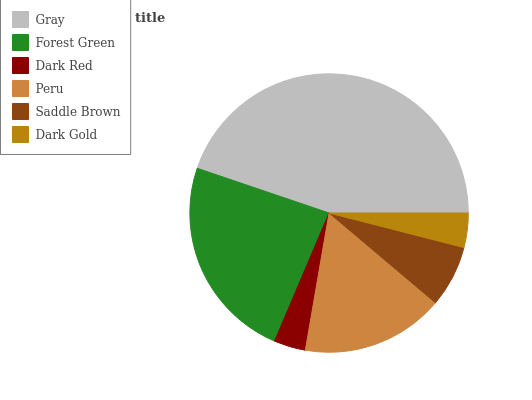Is Dark Red the minimum?
Answer yes or no. Yes. Is Gray the maximum?
Answer yes or no. Yes. Is Forest Green the minimum?
Answer yes or no. No. Is Forest Green the maximum?
Answer yes or no. No. Is Gray greater than Forest Green?
Answer yes or no. Yes. Is Forest Green less than Gray?
Answer yes or no. Yes. Is Forest Green greater than Gray?
Answer yes or no. No. Is Gray less than Forest Green?
Answer yes or no. No. Is Peru the high median?
Answer yes or no. Yes. Is Saddle Brown the low median?
Answer yes or no. Yes. Is Gray the high median?
Answer yes or no. No. Is Gray the low median?
Answer yes or no. No. 